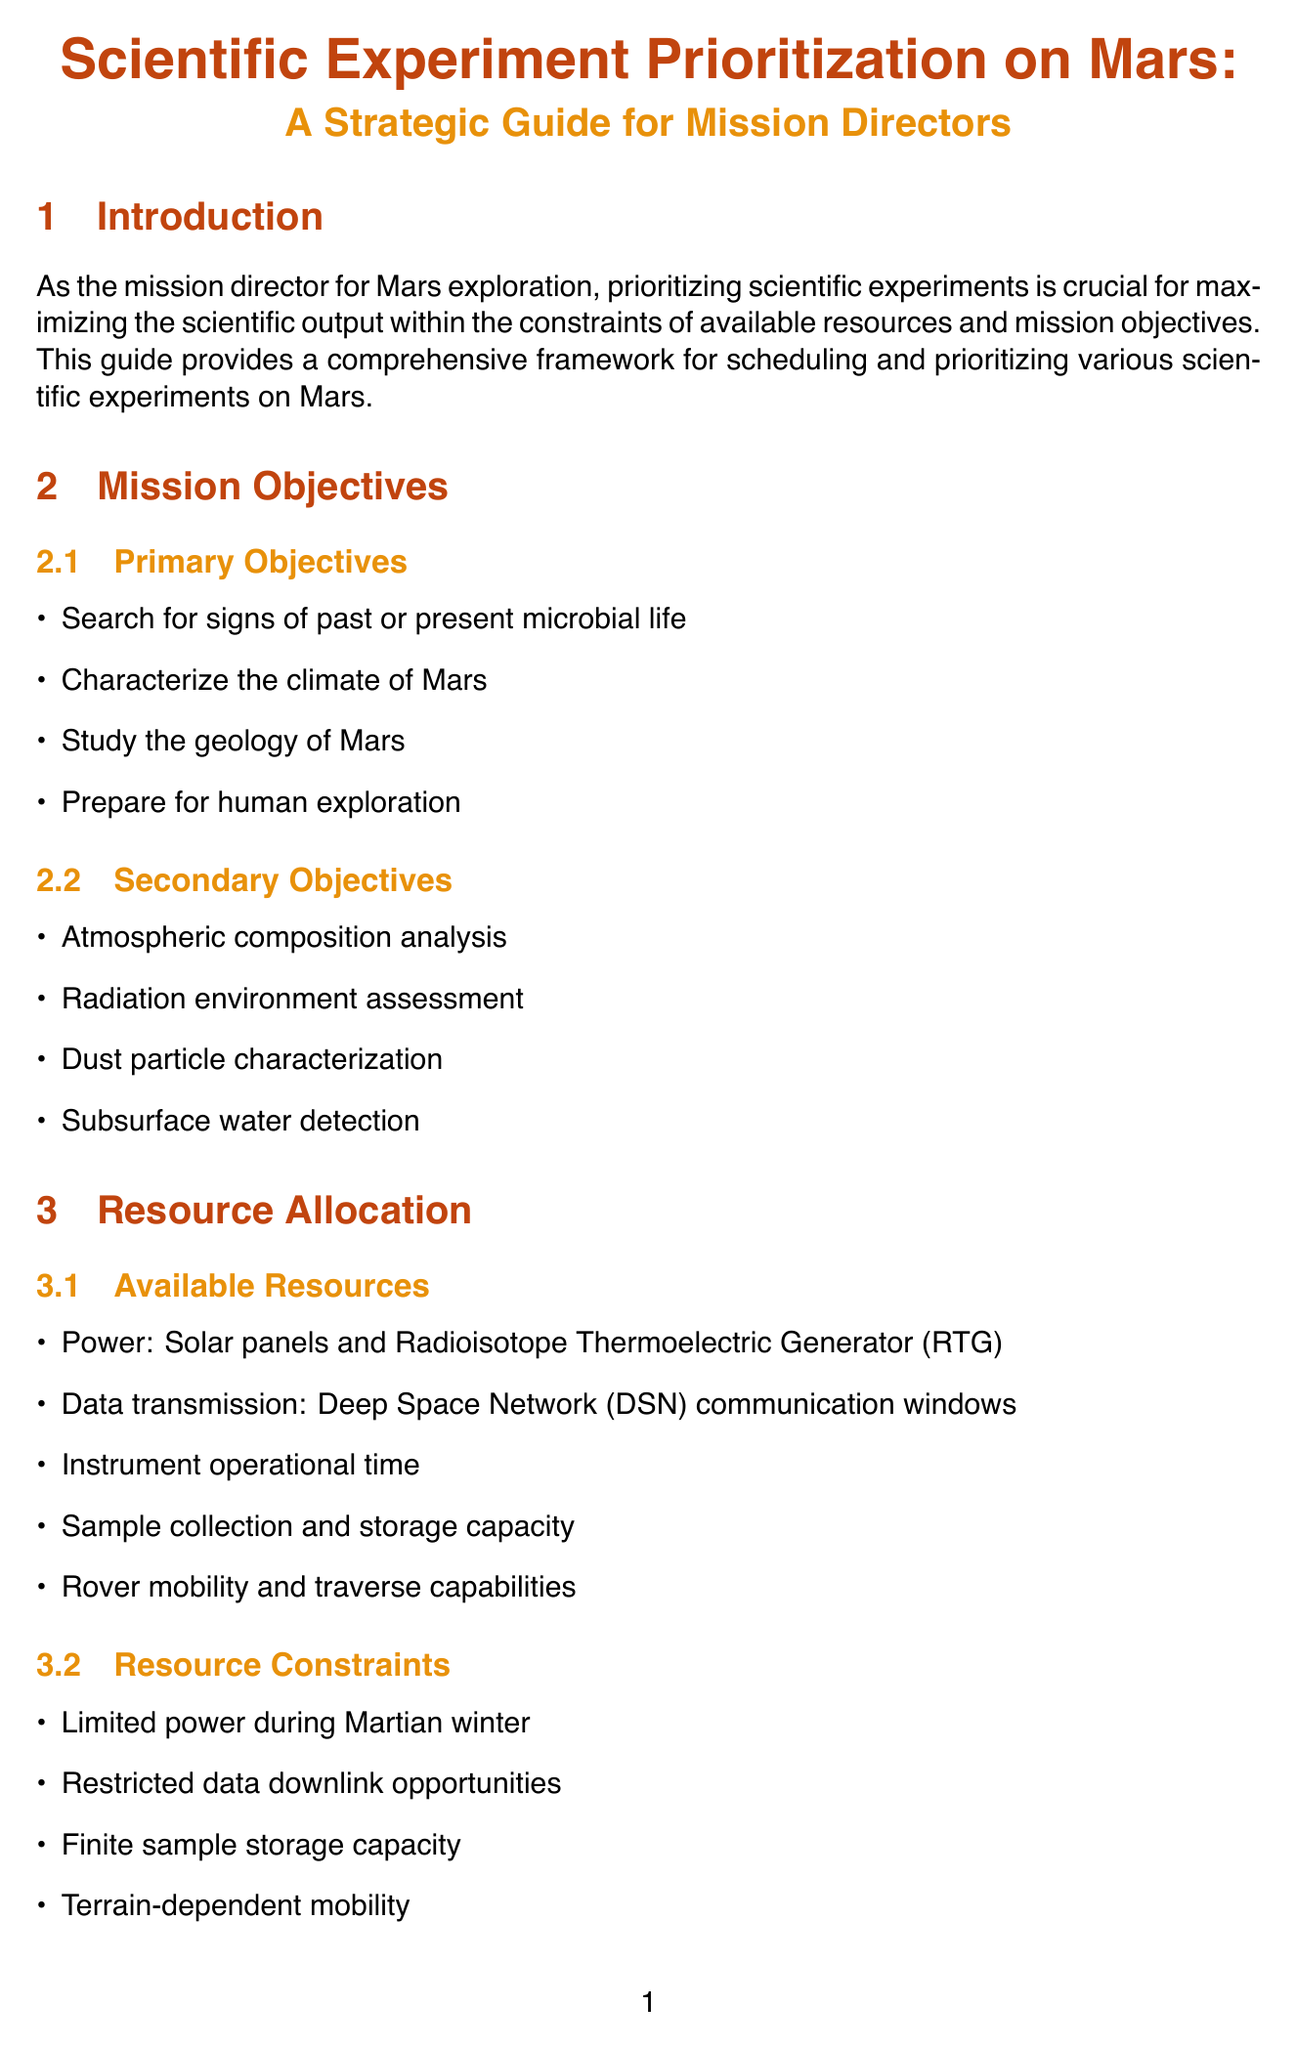what is the title of the manual? The title of the manual is specified at the beginning of the document.
Answer: Scientific Experiment Prioritization on Mars: A Strategic Guide for Mission Directors how many primary objectives are listed? The document states the number of primary objectives under the "Mission Objectives" section.
Answer: 4 name one high-priority experiment category. The document categorizes experiments based on their alignment with mission objectives.
Answer: Directly address primary objectives what is one available resource mentioned? The "Available Resources" subsection lists several resources available for the mission.
Answer: Solar panels what should be accounted for in long-term planning? The "Long-term Planning" subsection indicates considerations needed for effective planning.
Answer: Seasonal variations on Mars which instrument is mentioned for weather monitoring? The "Key Experiments and Instruments" section specifies instruments and their purposes.
Answer: Mars Environmental Dynamics Analyzer (MEDA) name one criterion for prioritization. The "Prioritization Criteria" section provides guidelines for examining experiments.
Answer: Scientific value and potential for groundbreaking discoveries which section addresses potential risks? The document outlines specific sections dealing with various aspects of experiment prioritization.
Answer: Risk Management what is one aim of adaptive prioritization? The document outlines the purpose of adaptive prioritization under its dedicated section.
Answer: Regularly reassess priorities based on new findings 